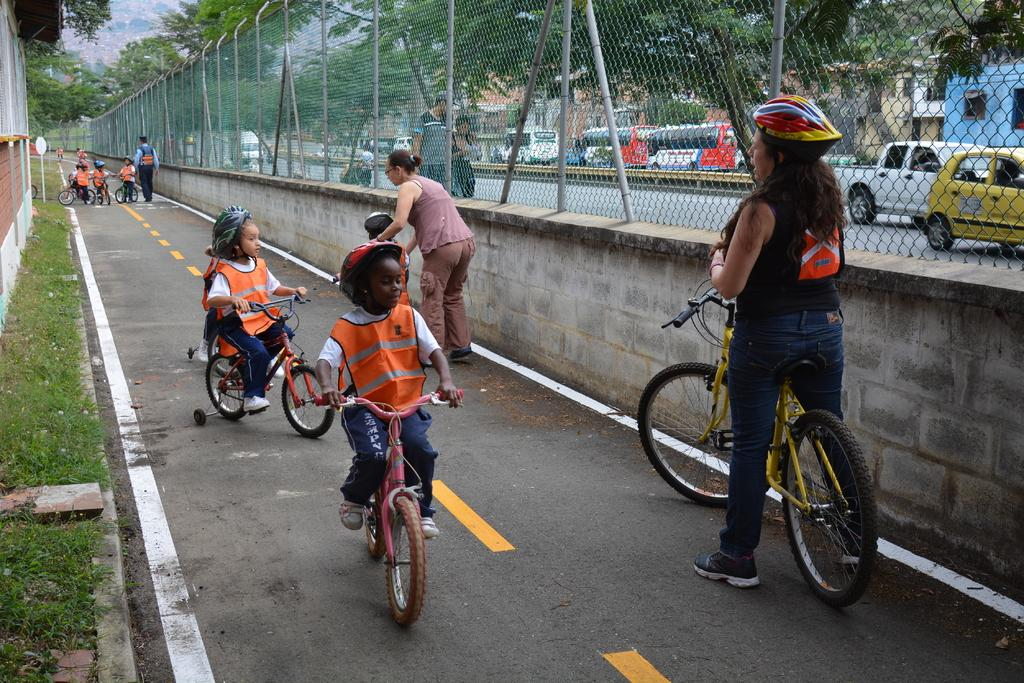What is the main setting of the image? The image depicts aicts a street. What are the children in the image doing? The children in the image are riding bicycles. Is there anyone else riding a cycle in the image? Yes, there is a lady riding a cycle in the image. What type of vehicles can be seen in the image? Cars are visible in the image. What can be seen in the background of the image? There are trees present in the image. What type of waves can be seen crashing on the shore in the image? There are no waves or shore present in the image; it depicts a street with people riding bicycles and cars. 